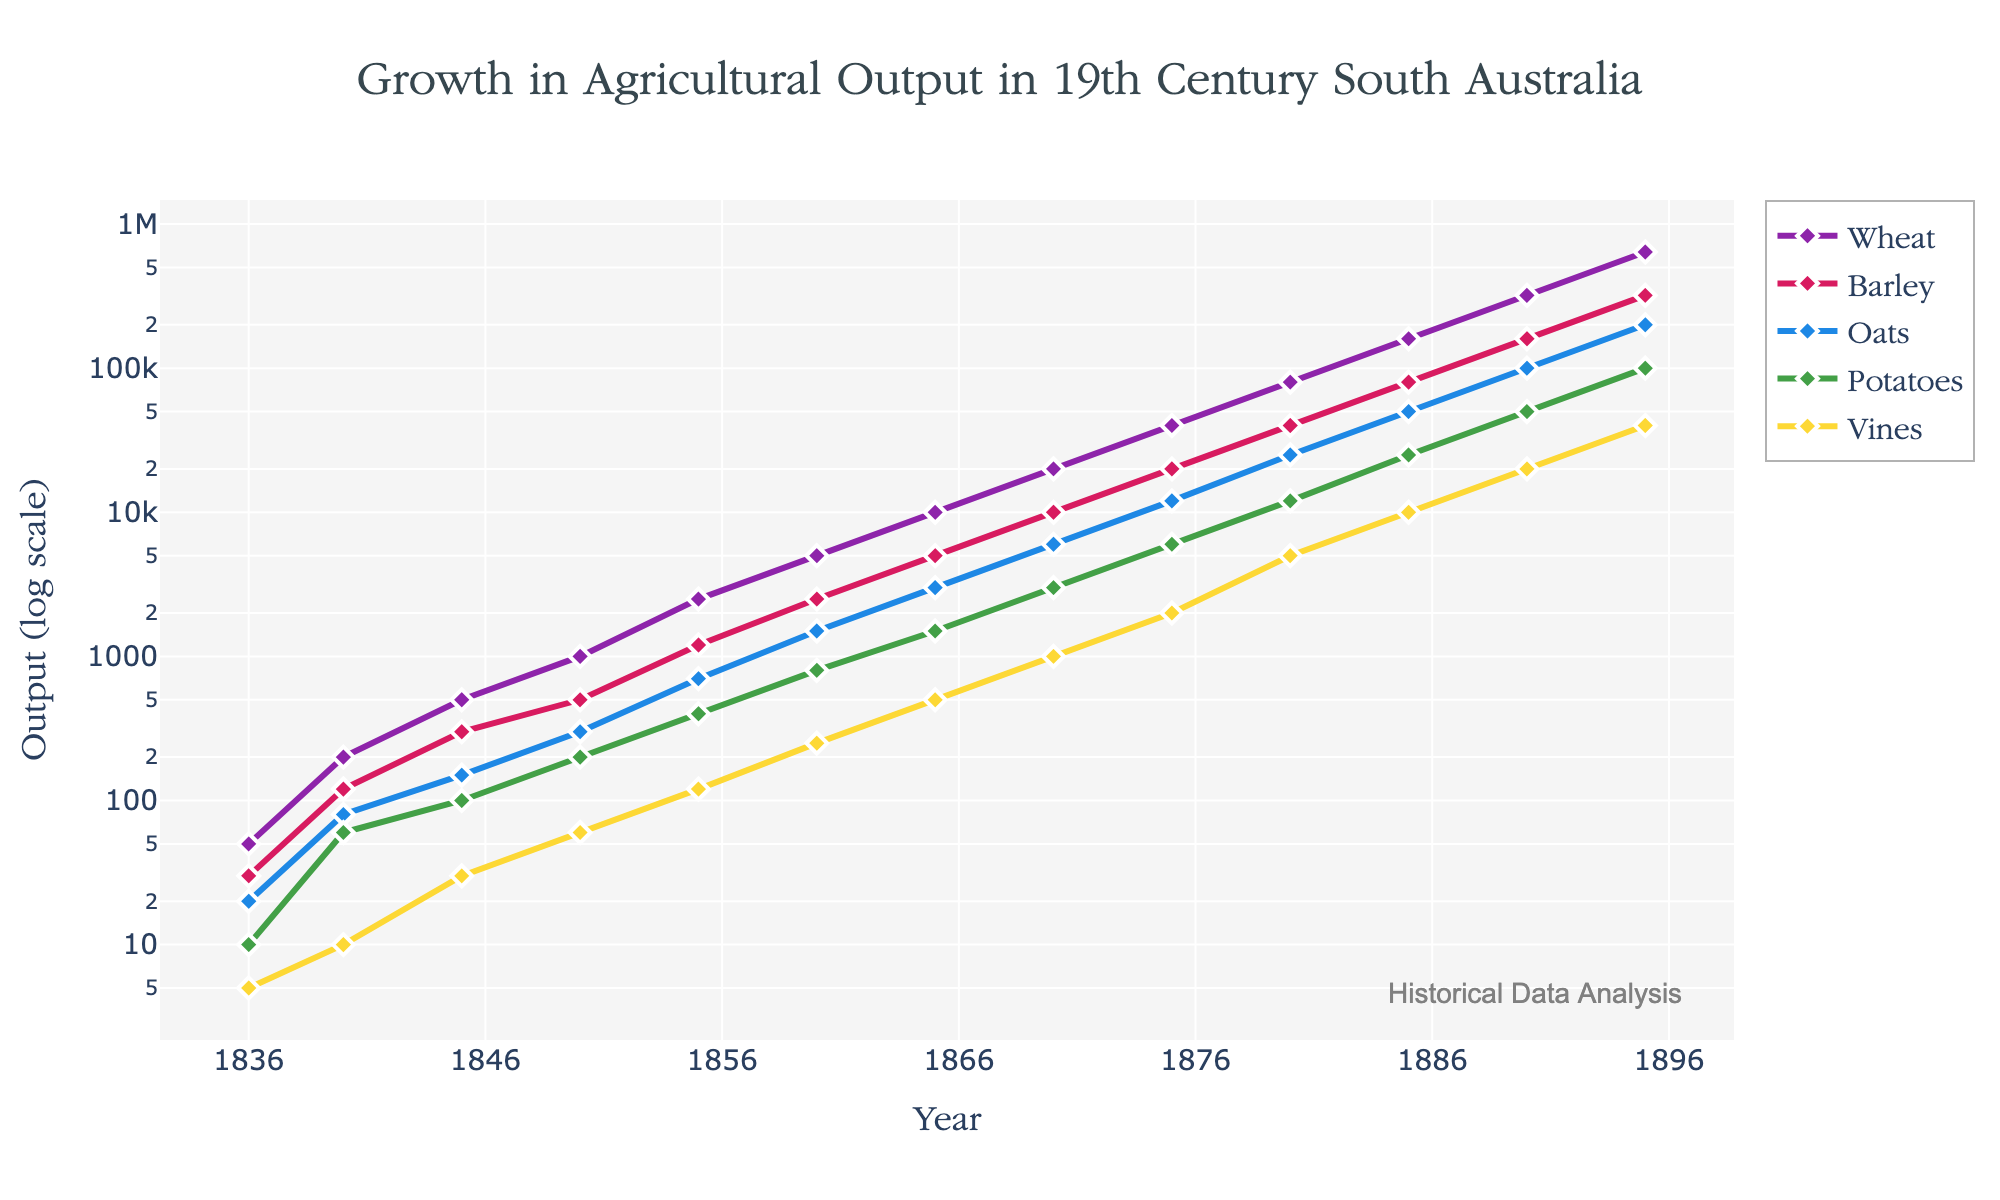What is the title of the figure? The title of the figure is displayed prominently at the top of the chart, describing the visualized data.
Answer: Growth in Agricultural Output in 19th Century South Australia What are the crops shown in the figure? The figure includes five colored lines, each representing a different crop. The crops are indicated in the legend.
Answer: Wheat, Barley, Oats, Potatoes, Vines How does the output of Wheat in 1890 compare to that in 1860? Locate the vertical positions of the Wheat data points for the years 1860 and 1890. The Wheat output in 1890 is significantly higher.
Answer: Wheat output in 1890 is much higher than in 1860 Which crop had the least output in 1836, and what was it? Observe the lowest position of data points among the crops for the year 1836.
Answer: Vines with an output of 5 What is the general trend of agricultural output over the 19th century? Observe the overall direction in which all crops increase. All crop output values rise logarithmically over time, showing growth.
Answer: Upward Between which years did Potatoes experience the largest growth in output? Compare the differences in Potatoes' output visually year by year. The steepest increase can be observed between certain years.
Answer: 1836 and 1840 What is the median output value for Oats in the data shown? Identify and list all values for Oats, and determine the median value by arranging them in ascending order and picking the middle value.
Answer: 3000 How many data points are plotted for each crop in the figure? Count the number of years (x-axis values) for which data points are present for each crop. Each crop is plotted for every year in the 19th century sequence provided.
Answer: 13 Which crop shows the steepest increase in output from 1880 to 1895? Compare the slope of the lines representing each crop between these two years. The crop with the highest slope has the steepest increase.
Answer: Wheat In which year did Barley output reach 10,000? Examine the Barley data series and identify the year when it intersects the output value of 10,000.
Answer: 1870 If you were to plot another crop with its output doubling every year starting at 10 in 1836, where would it be in 1860? Determine 10 doubled every year for each year interval from 1836 to 1860 (24 years). Calculate and locate this value on a logarithmic scale.
Answer: Slightly above 16 million 